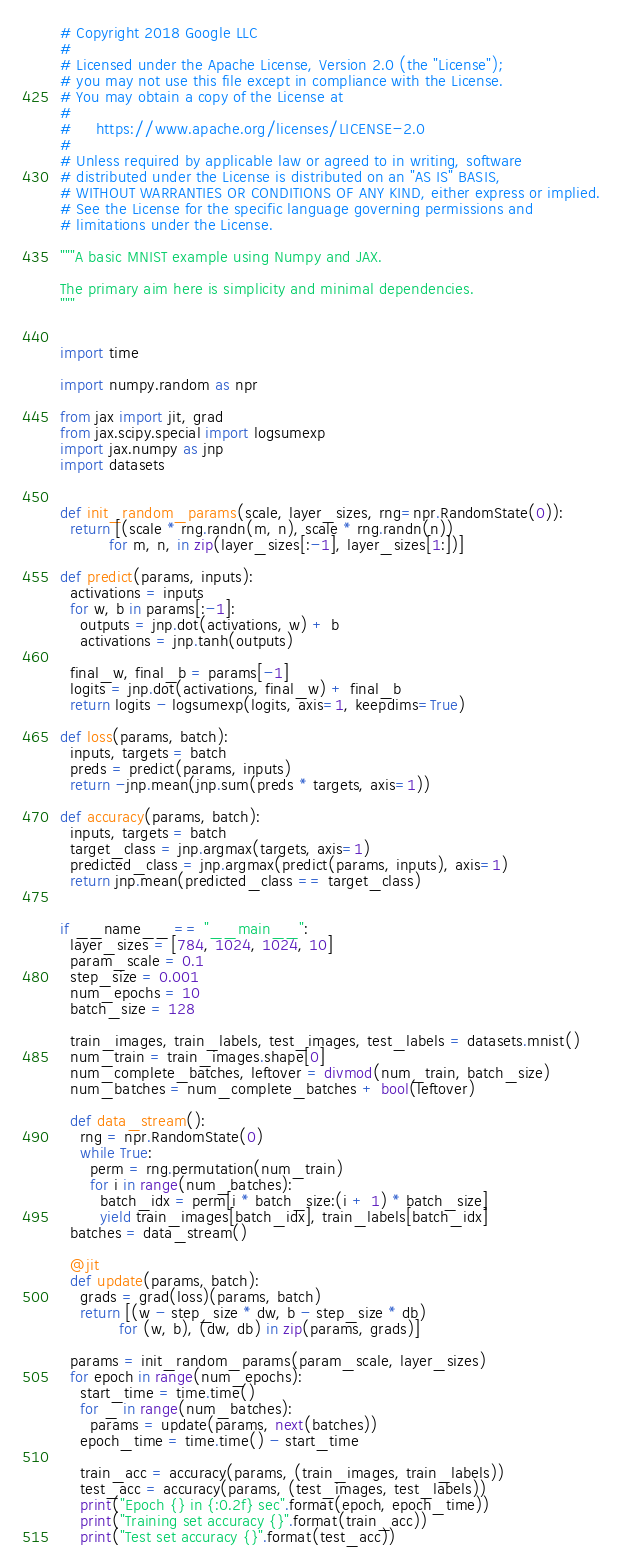<code> <loc_0><loc_0><loc_500><loc_500><_Python_># Copyright 2018 Google LLC
#
# Licensed under the Apache License, Version 2.0 (the "License");
# you may not use this file except in compliance with the License.
# You may obtain a copy of the License at
#
#     https://www.apache.org/licenses/LICENSE-2.0
#
# Unless required by applicable law or agreed to in writing, software
# distributed under the License is distributed on an "AS IS" BASIS,
# WITHOUT WARRANTIES OR CONDITIONS OF ANY KIND, either express or implied.
# See the License for the specific language governing permissions and
# limitations under the License.

"""A basic MNIST example using Numpy and JAX.

The primary aim here is simplicity and minimal dependencies.
"""


import time

import numpy.random as npr

from jax import jit, grad
from jax.scipy.special import logsumexp
import jax.numpy as jnp
import datasets


def init_random_params(scale, layer_sizes, rng=npr.RandomState(0)):
  return [(scale * rng.randn(m, n), scale * rng.randn(n))
          for m, n, in zip(layer_sizes[:-1], layer_sizes[1:])]

def predict(params, inputs):
  activations = inputs
  for w, b in params[:-1]:
    outputs = jnp.dot(activations, w) + b
    activations = jnp.tanh(outputs)

  final_w, final_b = params[-1]
  logits = jnp.dot(activations, final_w) + final_b
  return logits - logsumexp(logits, axis=1, keepdims=True)

def loss(params, batch):
  inputs, targets = batch
  preds = predict(params, inputs)
  return -jnp.mean(jnp.sum(preds * targets, axis=1))

def accuracy(params, batch):
  inputs, targets = batch
  target_class = jnp.argmax(targets, axis=1)
  predicted_class = jnp.argmax(predict(params, inputs), axis=1)
  return jnp.mean(predicted_class == target_class)


if __name__ == "__main__":
  layer_sizes = [784, 1024, 1024, 10]
  param_scale = 0.1
  step_size = 0.001
  num_epochs = 10
  batch_size = 128

  train_images, train_labels, test_images, test_labels = datasets.mnist()
  num_train = train_images.shape[0]
  num_complete_batches, leftover = divmod(num_train, batch_size)
  num_batches = num_complete_batches + bool(leftover)

  def data_stream():
    rng = npr.RandomState(0)
    while True:
      perm = rng.permutation(num_train)
      for i in range(num_batches):
        batch_idx = perm[i * batch_size:(i + 1) * batch_size]
        yield train_images[batch_idx], train_labels[batch_idx]
  batches = data_stream()

  @jit
  def update(params, batch):
    grads = grad(loss)(params, batch)
    return [(w - step_size * dw, b - step_size * db)
            for (w, b), (dw, db) in zip(params, grads)]

  params = init_random_params(param_scale, layer_sizes)
  for epoch in range(num_epochs):
    start_time = time.time()
    for _ in range(num_batches):
      params = update(params, next(batches))
    epoch_time = time.time() - start_time

    train_acc = accuracy(params, (train_images, train_labels))
    test_acc = accuracy(params, (test_images, test_labels))
    print("Epoch {} in {:0.2f} sec".format(epoch, epoch_time))
    print("Training set accuracy {}".format(train_acc))
    print("Test set accuracy {}".format(test_acc))
</code> 